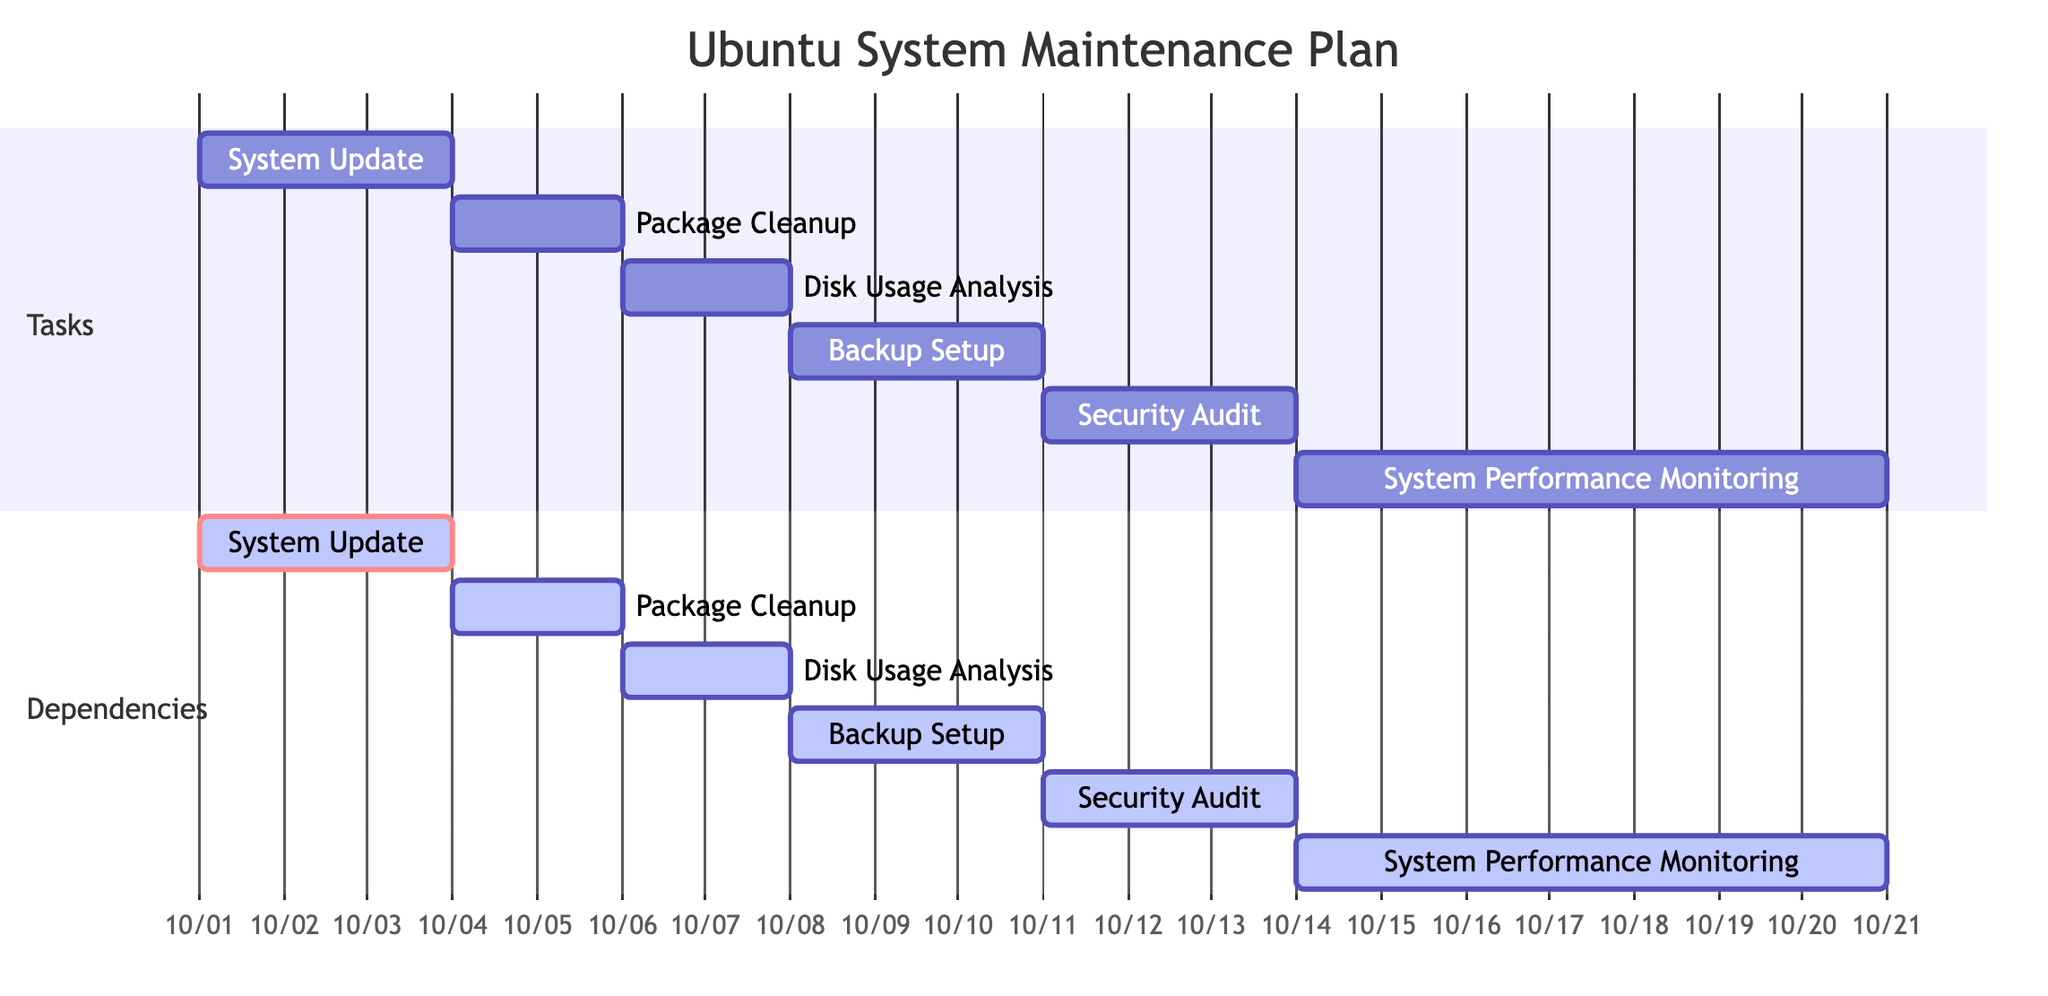What is the duration of the "Security Audit" task? The duration of the "Security Audit" task is provided in the data under the "duration" key. It lists the duration as "3 days."
Answer: 3 days What task does "Disk Usage Analysis" depend on? The dependencies listed for "Disk Usage Analysis" include only "Package Cleanup". This dependency is found under the "dependencies" key for the "Disk Usage Analysis" task.
Answer: Package Cleanup How many tasks are there in total? By listing out each task in the "maintenance_plan," there are six distinct tasks that can be counted.
Answer: 6 Which task is scheduled to start first? The first task listed in the provided data is "System Update," which starts on "2023-10-01". By checking the start dates of all tasks, this is the earliest one.
Answer: System Update What is the end date of the "Backup Setup" task? The end date for the "Backup Setup" task is given in the data as "2023-10-10". This is found under the "end_date" key for that specific task.
Answer: 2023-10-10 What is the total duration of all tasks combined? To calculate the total duration, add together the durations of each individual task: 3 days (System Update) + 2 days (Package Cleanup) + 2 days (Disk Usage Analysis) + 3 days (Backup Setup) + 3 days (Security Audit) + 7 days (System Performance Monitoring) equals 20 days.
Answer: 20 days Which task follows "Security Audit" in the timeline? By examining the dependencies and timelines, "System Performance Monitoring" starts immediately after the completion of "Security Audit" and is the next task listed. Therefore, it directly follows it.
Answer: System Performance Monitoring When is the "Start" date for the "Package Cleanup" task? The "start_date" for "Package Cleanup" is provided as "2023-10-04". This information can be found directly in the data under the corresponding task.
Answer: 2023-10-04 How many days is the "System Performance Monitoring" task scheduled for? The duration for "System Performance Monitoring" is explicitly mentioned in the data as "7 days." This is found under its specific task details in the "duration" key.
Answer: 7 days 